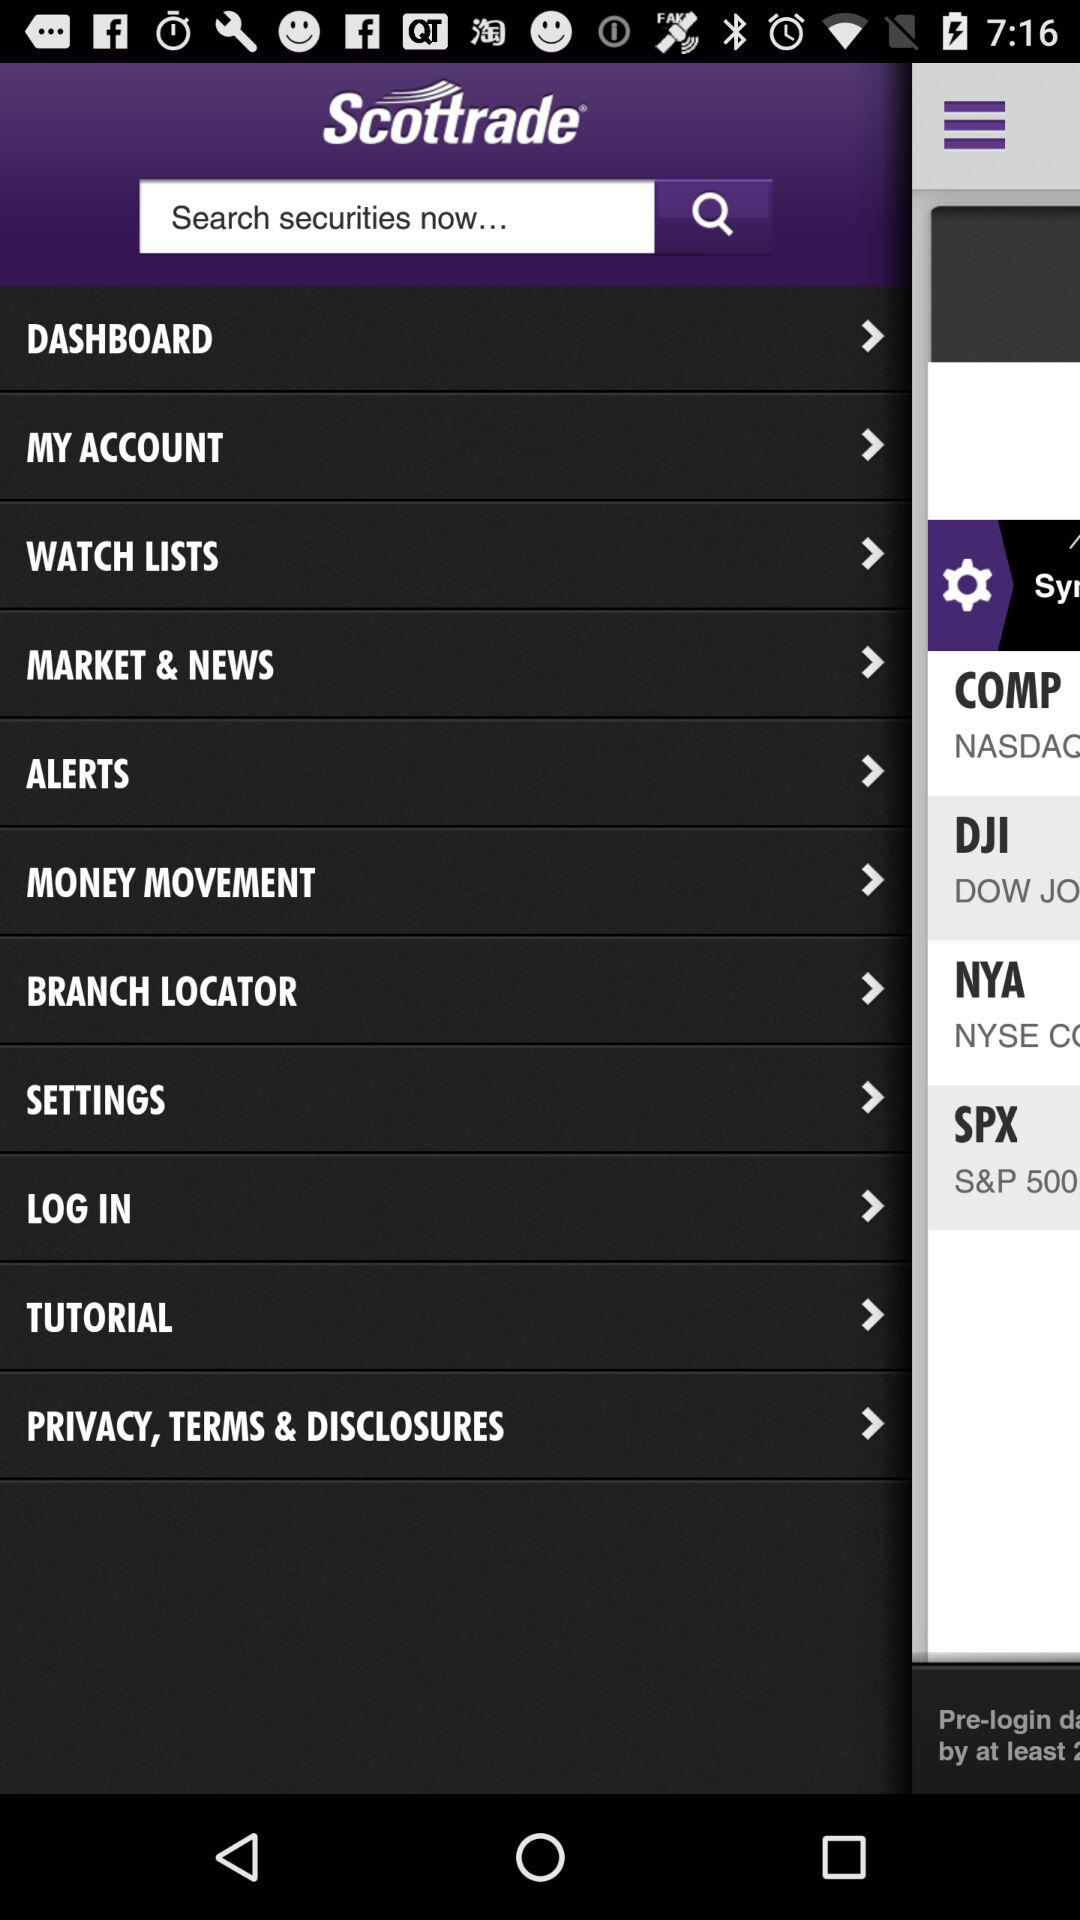What is the name of the application? The name of the application is "Scottrade". 